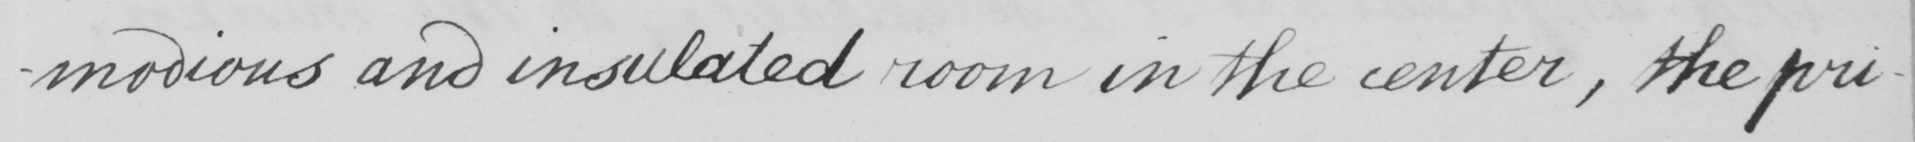What does this handwritten line say? -modious and insulated room in the center , the pri- 